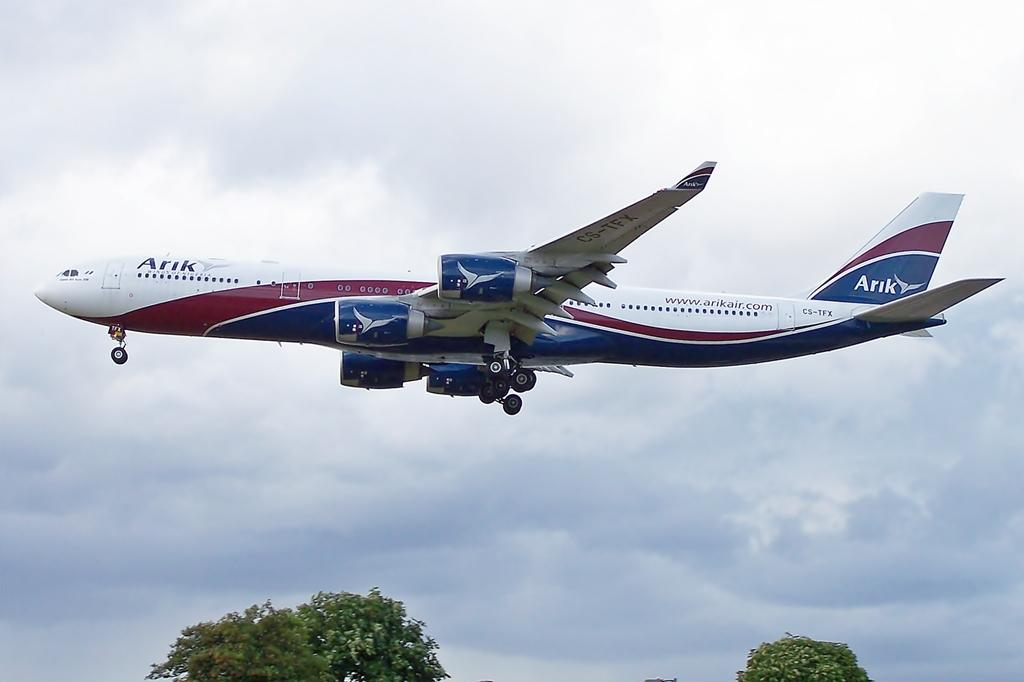What is the main subject of the image? The main subject of the image is an airplane. What is the airplane doing in the image? The airplane is flying in the sky. What type of natural scenery can be seen in the image? Trees are visible in the image. What is the condition of the sky in the image? The sky appears to be cloudy in the image. What type of crib is visible in the image? There is no crib present in the image; it features an airplane flying in the sky. What type of coat is being worn by the airplane in the image? Airplanes do not wear coats; they are not living beings and do not require clothing. 